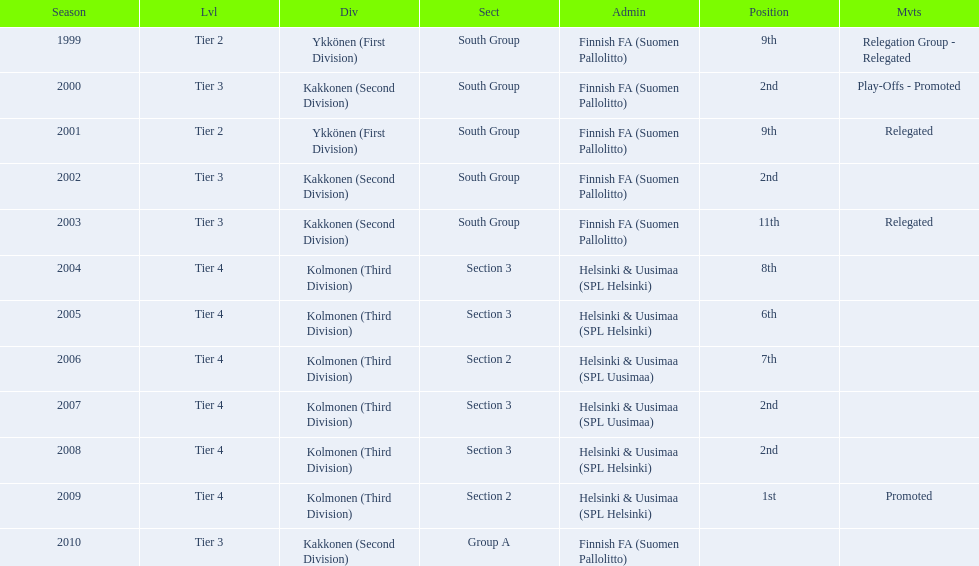Which was the only kolmonen whose movements were promoted? 2009. 